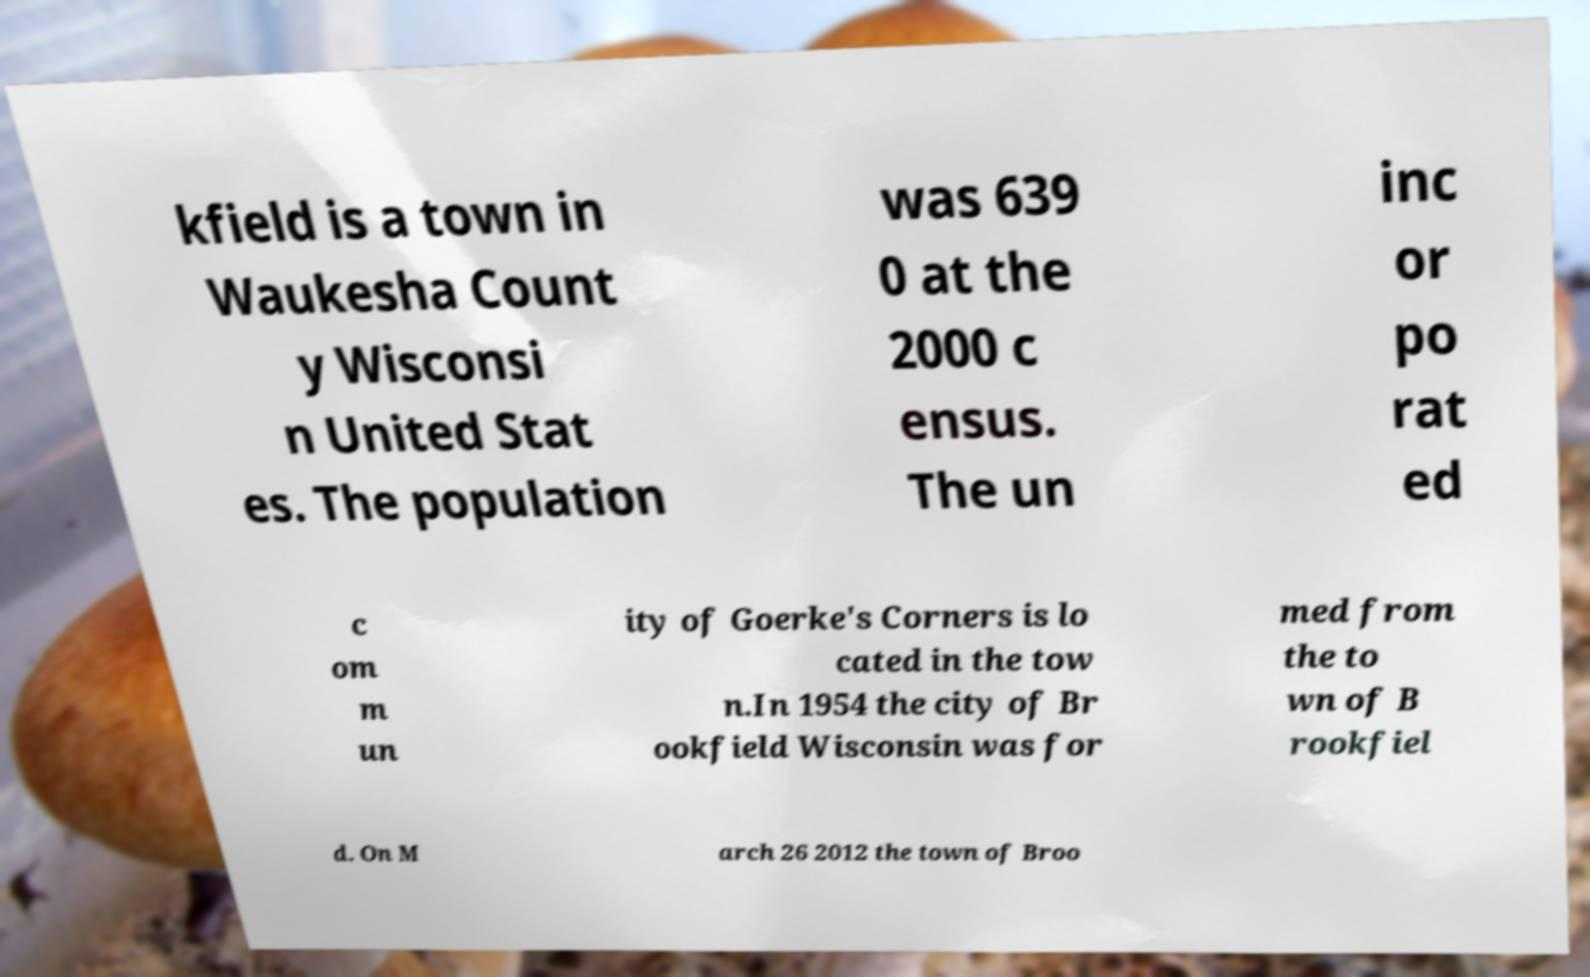Can you read and provide the text displayed in the image?This photo seems to have some interesting text. Can you extract and type it out for me? kfield is a town in Waukesha Count y Wisconsi n United Stat es. The population was 639 0 at the 2000 c ensus. The un inc or po rat ed c om m un ity of Goerke's Corners is lo cated in the tow n.In 1954 the city of Br ookfield Wisconsin was for med from the to wn of B rookfiel d. On M arch 26 2012 the town of Broo 